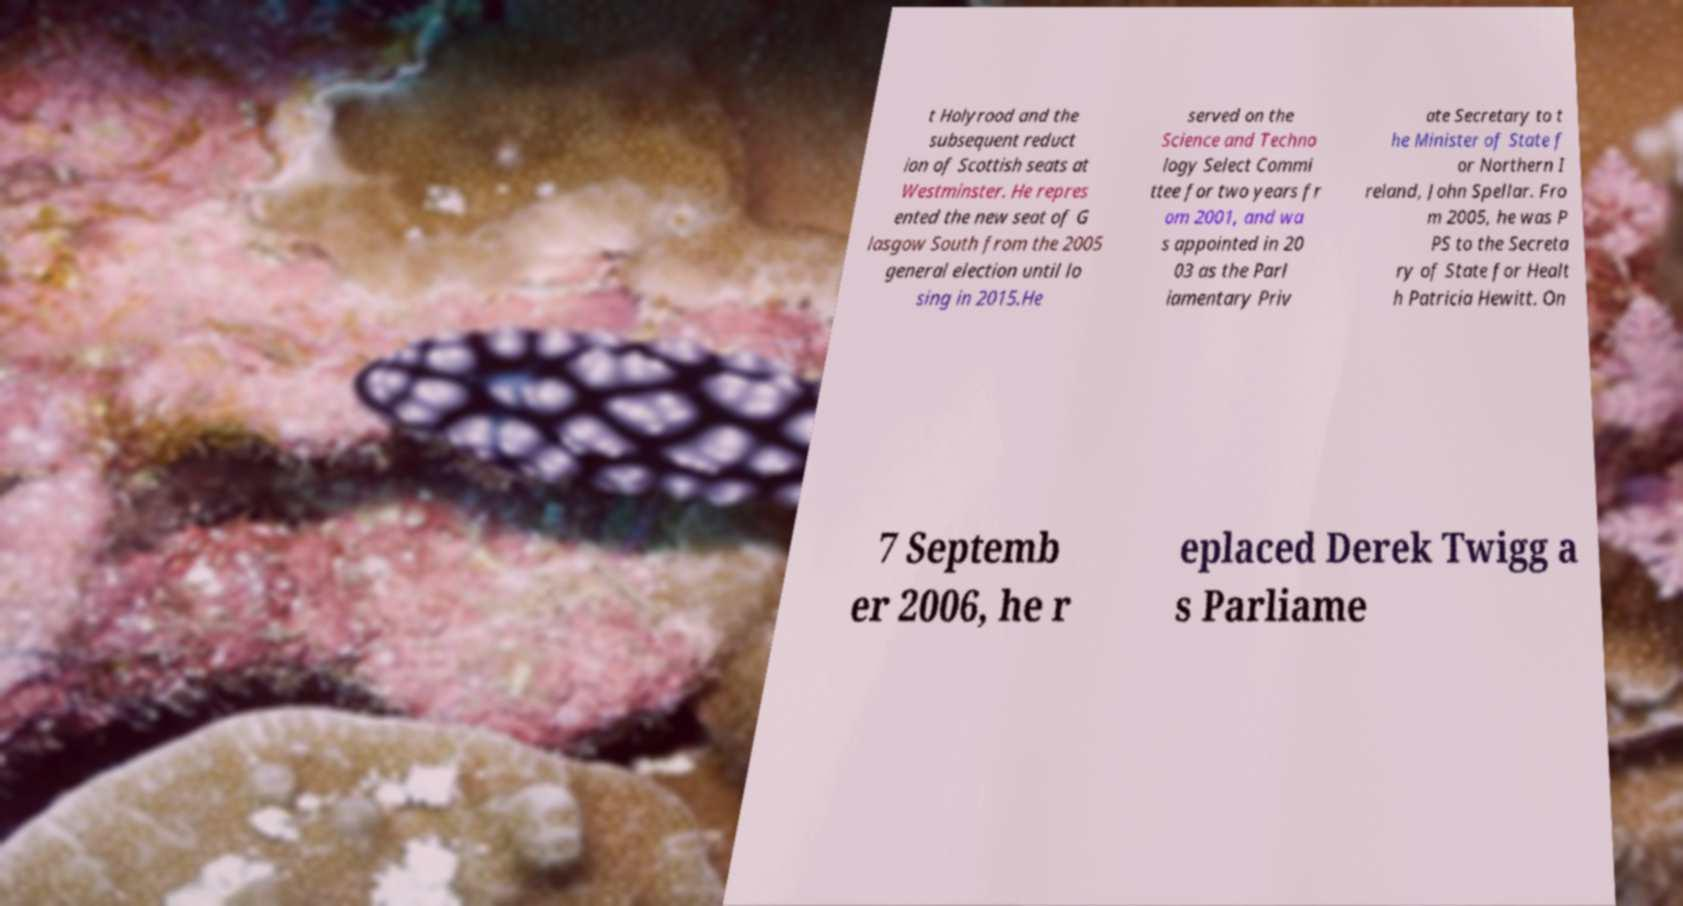I need the written content from this picture converted into text. Can you do that? t Holyrood and the subsequent reduct ion of Scottish seats at Westminster. He repres ented the new seat of G lasgow South from the 2005 general election until lo sing in 2015.He served on the Science and Techno logy Select Commi ttee for two years fr om 2001, and wa s appointed in 20 03 as the Parl iamentary Priv ate Secretary to t he Minister of State f or Northern I reland, John Spellar. Fro m 2005, he was P PS to the Secreta ry of State for Healt h Patricia Hewitt. On 7 Septemb er 2006, he r eplaced Derek Twigg a s Parliame 